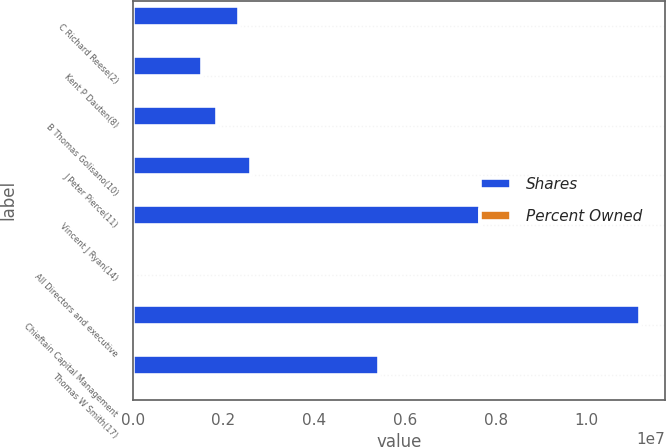Convert chart to OTSL. <chart><loc_0><loc_0><loc_500><loc_500><stacked_bar_chart><ecel><fcel>C Richard Reese(2)<fcel>Kent P Dauten(8)<fcel>B Thomas Golisano(10)<fcel>J Peter Pierce(11)<fcel>Vincent J Ryan(14)<fcel>All Directors and executive<fcel>Chieftain Capital Management<fcel>Thomas W Smith(17)<nl><fcel>Shares<fcel>2.34144e+06<fcel>1.52532e+06<fcel>1.86779e+06<fcel>2.59672e+06<fcel>7.65567e+06<fcel>18.3<fcel>1.11671e+07<fcel>5.42406e+06<nl><fcel>Percent Owned<fcel>2.8<fcel>1.8<fcel>2.2<fcel>3.1<fcel>9.1<fcel>18.3<fcel>13.3<fcel>6.4<nl></chart> 